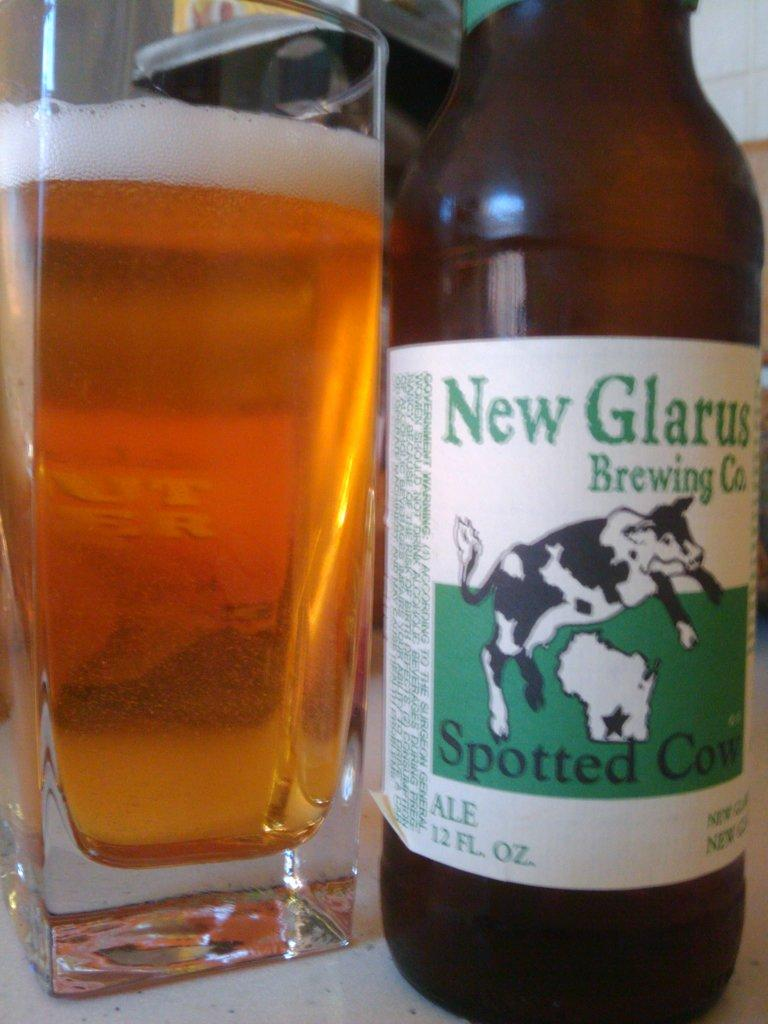<image>
Summarize the visual content of the image. A cow covered with spots is depicted on the label of a bottle of Spotted Cow beer. 